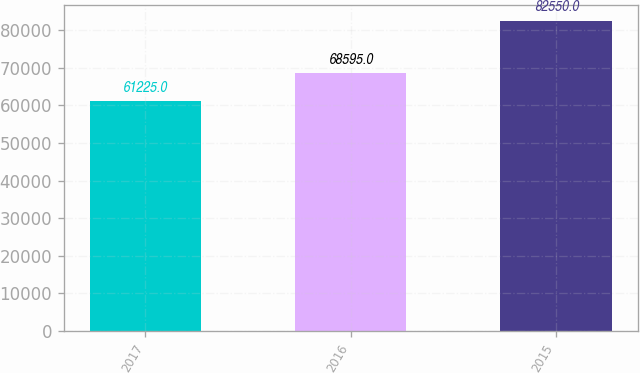Convert chart. <chart><loc_0><loc_0><loc_500><loc_500><bar_chart><fcel>2017<fcel>2016<fcel>2015<nl><fcel>61225<fcel>68595<fcel>82550<nl></chart> 